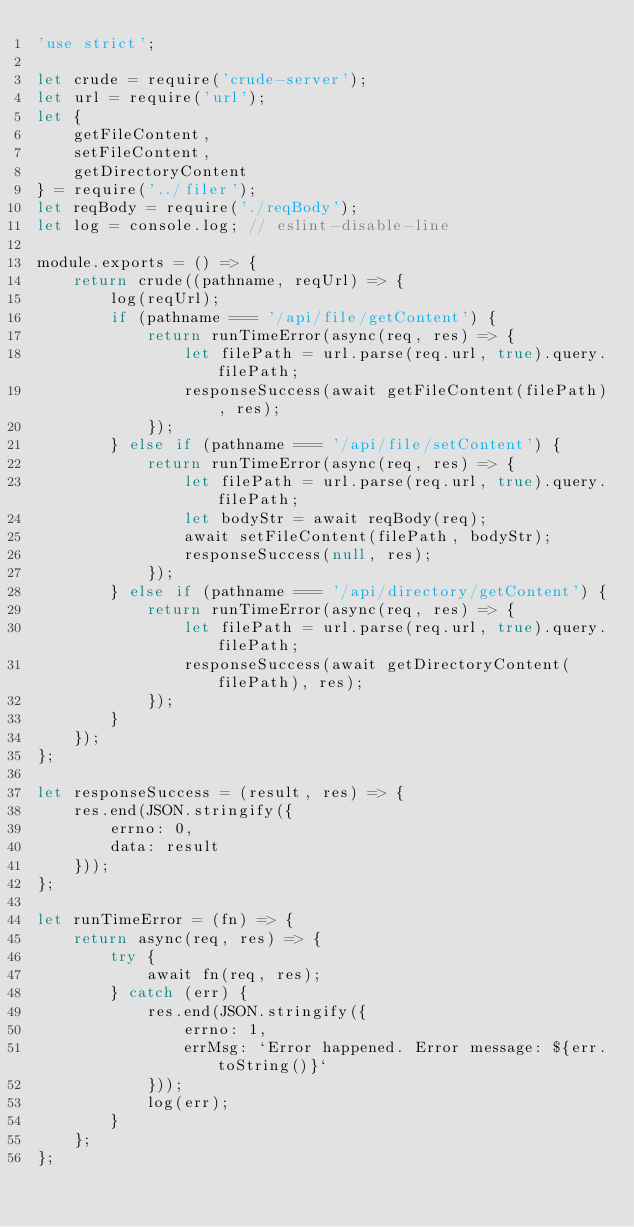Convert code to text. <code><loc_0><loc_0><loc_500><loc_500><_JavaScript_>'use strict';

let crude = require('crude-server');
let url = require('url');
let {
    getFileContent,
    setFileContent,
    getDirectoryContent
} = require('../filer');
let reqBody = require('./reqBody');
let log = console.log; // eslint-disable-line

module.exports = () => {
    return crude((pathname, reqUrl) => {
        log(reqUrl);
        if (pathname === '/api/file/getContent') {
            return runTimeError(async(req, res) => {
                let filePath = url.parse(req.url, true).query.filePath;
                responseSuccess(await getFileContent(filePath), res);
            });
        } else if (pathname === '/api/file/setContent') {
            return runTimeError(async(req, res) => {
                let filePath = url.parse(req.url, true).query.filePath;
                let bodyStr = await reqBody(req);
                await setFileContent(filePath, bodyStr);
                responseSuccess(null, res);
            });
        } else if (pathname === '/api/directory/getContent') {
            return runTimeError(async(req, res) => {
                let filePath = url.parse(req.url, true).query.filePath;
                responseSuccess(await getDirectoryContent(filePath), res);
            });
        }
    });
};

let responseSuccess = (result, res) => {
    res.end(JSON.stringify({
        errno: 0,
        data: result
    }));
};

let runTimeError = (fn) => {
    return async(req, res) => {
        try {
            await fn(req, res);
        } catch (err) {
            res.end(JSON.stringify({
                errno: 1,
                errMsg: `Error happened. Error message: ${err.toString()}`
            }));
            log(err);
        }
    };
};
</code> 